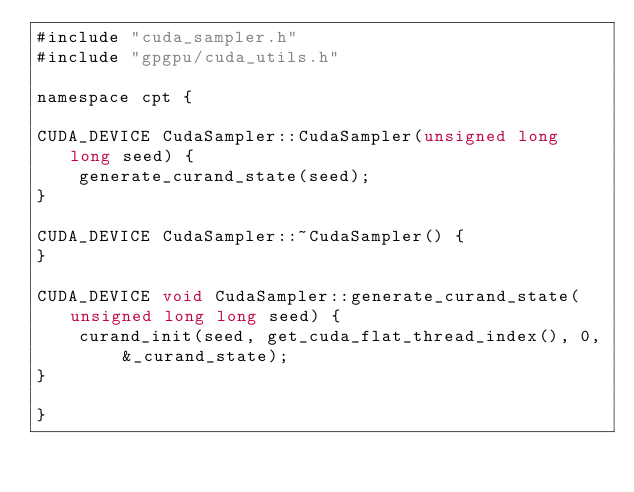<code> <loc_0><loc_0><loc_500><loc_500><_Cuda_>#include "cuda_sampler.h"
#include "gpgpu/cuda_utils.h"

namespace cpt {

CUDA_DEVICE CudaSampler::CudaSampler(unsigned long long seed) {
    generate_curand_state(seed); 
}

CUDA_DEVICE CudaSampler::~CudaSampler() {
}

CUDA_DEVICE void CudaSampler::generate_curand_state(unsigned long long seed) {
    curand_init(seed, get_cuda_flat_thread_index(), 0, &_curand_state);
}

}
</code> 